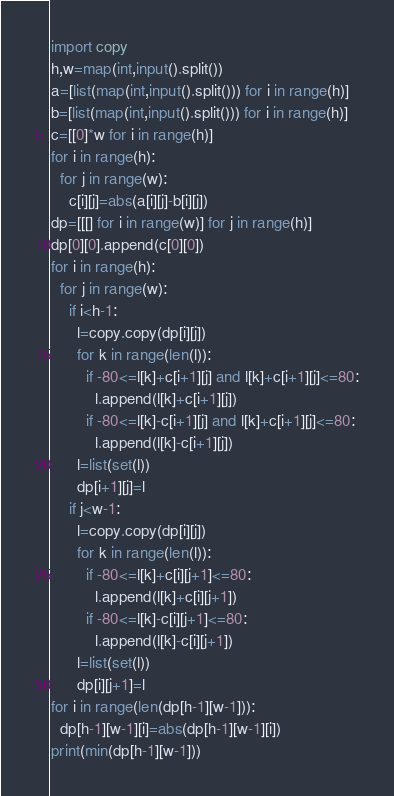Convert code to text. <code><loc_0><loc_0><loc_500><loc_500><_Python_>import copy
h,w=map(int,input().split())
a=[list(map(int,input().split())) for i in range(h)]
b=[list(map(int,input().split())) for i in range(h)]
c=[[0]*w for i in range(h)]
for i in range(h):
  for j in range(w):
    c[i][j]=abs(a[i][j]-b[i][j])
dp=[[[] for i in range(w)] for j in range(h)]
dp[0][0].append(c[0][0])
for i in range(h):
  for j in range(w):
    if i<h-1:
      l=copy.copy(dp[i][j])
      for k in range(len(l)):
        if -80<=l[k]+c[i+1][j] and l[k]+c[i+1][j]<=80:
          l.append(l[k]+c[i+1][j])
        if -80<=l[k]-c[i+1][j] and l[k]+c[i+1][j]<=80:
          l.append(l[k]-c[i+1][j])
      l=list(set(l))
      dp[i+1][j]=l
    if j<w-1:
      l=copy.copy(dp[i][j])
      for k in range(len(l)):
        if -80<=l[k]+c[i][j+1]<=80:
          l.append(l[k]+c[i][j+1])
        if -80<=l[k]-c[i][j+1]<=80:
          l.append(l[k]-c[i][j+1])
      l=list(set(l))
      dp[i][j+1]=l
for i in range(len(dp[h-1][w-1])):
  dp[h-1][w-1][i]=abs(dp[h-1][w-1][i])
print(min(dp[h-1][w-1]))</code> 